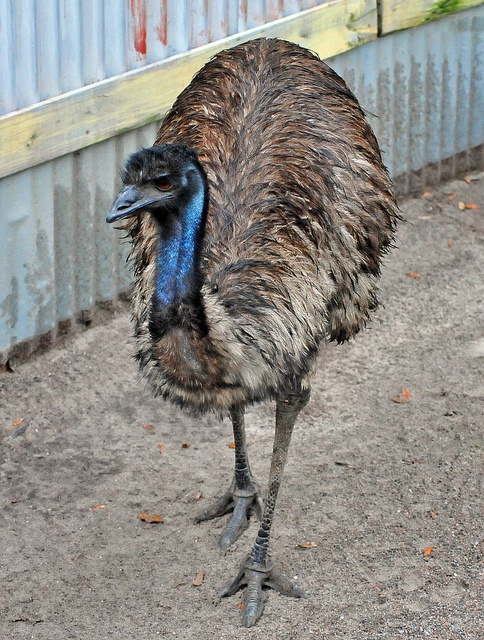Describe the objects in this image and their specific colors. I can see a bird in lightblue, gray, darkgray, and black tones in this image. 